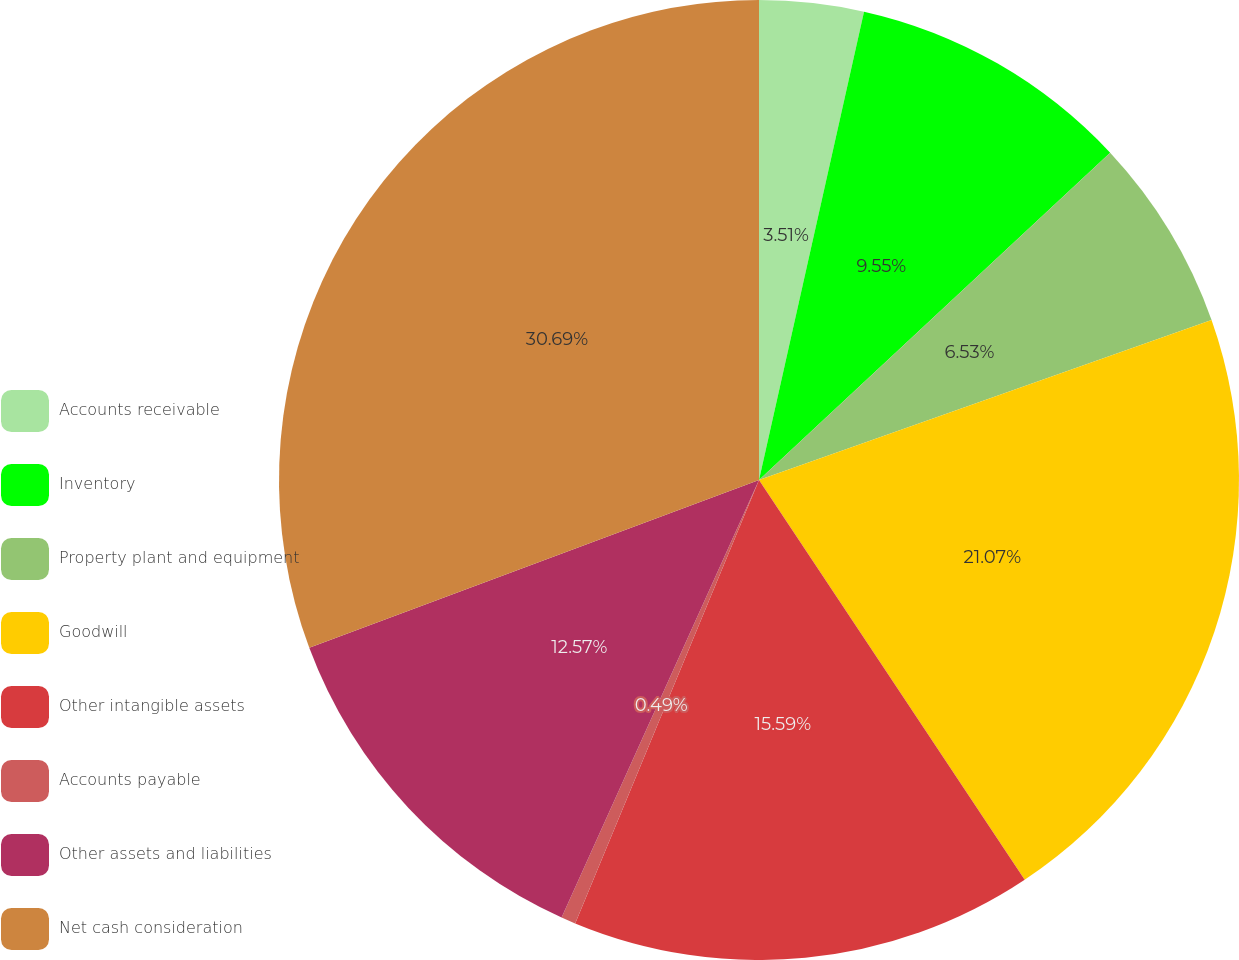<chart> <loc_0><loc_0><loc_500><loc_500><pie_chart><fcel>Accounts receivable<fcel>Inventory<fcel>Property plant and equipment<fcel>Goodwill<fcel>Other intangible assets<fcel>Accounts payable<fcel>Other assets and liabilities<fcel>Net cash consideration<nl><fcel>3.51%<fcel>9.55%<fcel>6.53%<fcel>21.07%<fcel>15.59%<fcel>0.49%<fcel>12.57%<fcel>30.68%<nl></chart> 